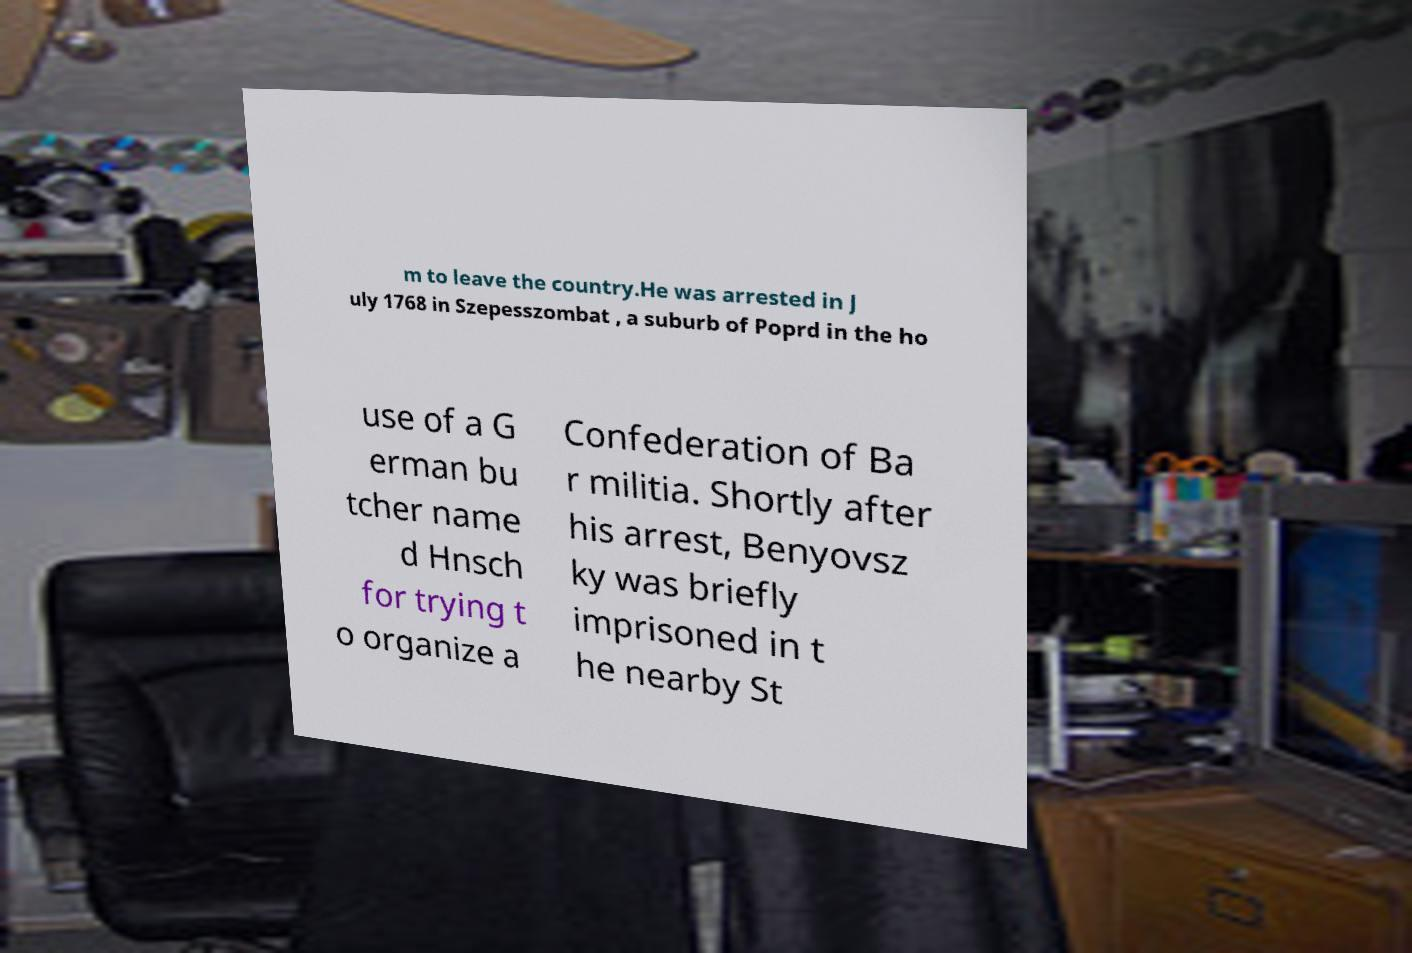Can you accurately transcribe the text from the provided image for me? m to leave the country.He was arrested in J uly 1768 in Szepesszombat , a suburb of Poprd in the ho use of a G erman bu tcher name d Hnsch for trying t o organize a Confederation of Ba r militia. Shortly after his arrest, Benyovsz ky was briefly imprisoned in t he nearby St 